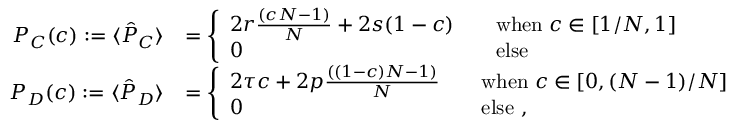<formula> <loc_0><loc_0><loc_500><loc_500>\begin{array} { r l } { P _ { C } ( c ) \colon = \langle \hat { P } _ { C } \rangle } & { = \left \{ \begin{array} { l l } { 2 r \frac { ( c N - 1 ) } { N } + 2 s ( 1 - c ) \quad } & { w h e n \, c \in [ 1 / N , 1 ] } \\ { 0 } & { e l s e } \end{array} } \\ { P _ { D } ( c ) \colon = \langle \hat { P } _ { D } \rangle } & { = \left \{ \begin{array} { l l } { 2 \tau c + 2 p \frac { ( ( 1 - c ) N - 1 ) } { N } \quad } & { w h e n \, c \in [ 0 , ( N - 1 ) / N ] } \\ { 0 } & { e l s e , } \end{array} } \end{array}</formula> 